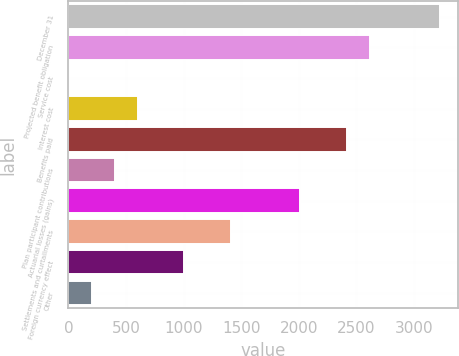Convert chart. <chart><loc_0><loc_0><loc_500><loc_500><bar_chart><fcel>December 31<fcel>Projected benefit obligation<fcel>Service cost<fcel>Interest cost<fcel>Benefits paid<fcel>Plan participant contributions<fcel>Actuarial losses (gains)<fcel>Settlements and curtailments<fcel>Foreign currency effect<fcel>Other<nl><fcel>3222.34<fcel>2618.17<fcel>0.1<fcel>604.27<fcel>2416.78<fcel>402.88<fcel>2014<fcel>1409.83<fcel>1007.05<fcel>201.49<nl></chart> 